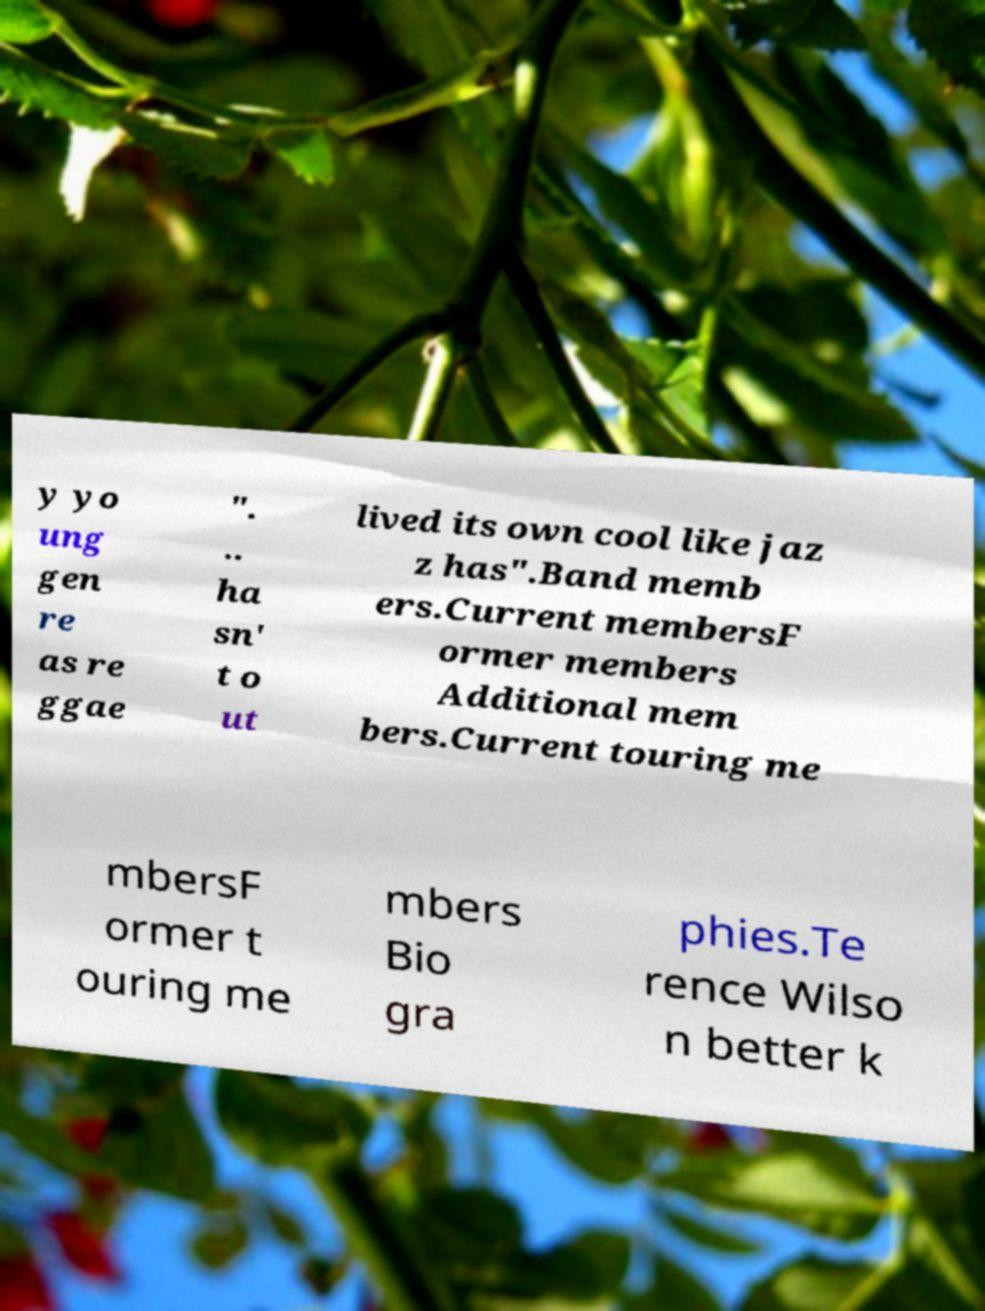Could you assist in decoding the text presented in this image and type it out clearly? y yo ung gen re as re ggae ". .. ha sn' t o ut lived its own cool like jaz z has".Band memb ers.Current membersF ormer members Additional mem bers.Current touring me mbersF ormer t ouring me mbers Bio gra phies.Te rence Wilso n better k 